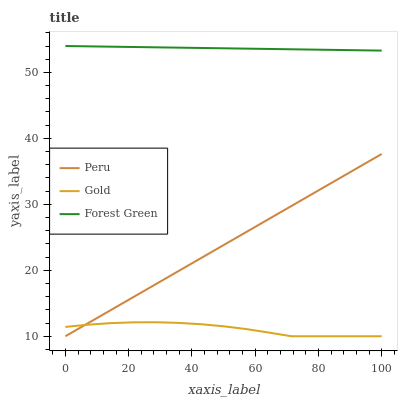Does Gold have the minimum area under the curve?
Answer yes or no. Yes. Does Forest Green have the maximum area under the curve?
Answer yes or no. Yes. Does Peru have the minimum area under the curve?
Answer yes or no. No. Does Peru have the maximum area under the curve?
Answer yes or no. No. Is Peru the smoothest?
Answer yes or no. Yes. Is Gold the roughest?
Answer yes or no. Yes. Is Gold the smoothest?
Answer yes or no. No. Is Peru the roughest?
Answer yes or no. No. Does Gold have the lowest value?
Answer yes or no. Yes. Does Forest Green have the highest value?
Answer yes or no. Yes. Does Peru have the highest value?
Answer yes or no. No. Is Gold less than Forest Green?
Answer yes or no. Yes. Is Forest Green greater than Gold?
Answer yes or no. Yes. Does Peru intersect Gold?
Answer yes or no. Yes. Is Peru less than Gold?
Answer yes or no. No. Is Peru greater than Gold?
Answer yes or no. No. Does Gold intersect Forest Green?
Answer yes or no. No. 